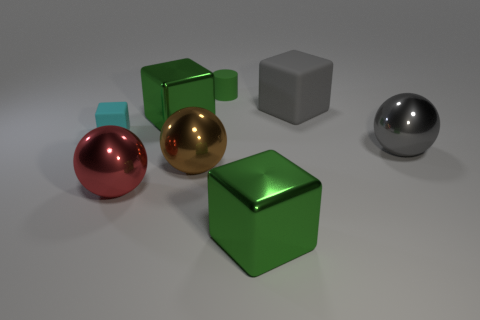Subtract 1 blocks. How many blocks are left? 3 Add 1 tiny things. How many objects exist? 9 Subtract all spheres. How many objects are left? 5 Add 3 matte cylinders. How many matte cylinders exist? 4 Subtract 0 green spheres. How many objects are left? 8 Subtract all big red balls. Subtract all red shiny objects. How many objects are left? 6 Add 8 brown spheres. How many brown spheres are left? 9 